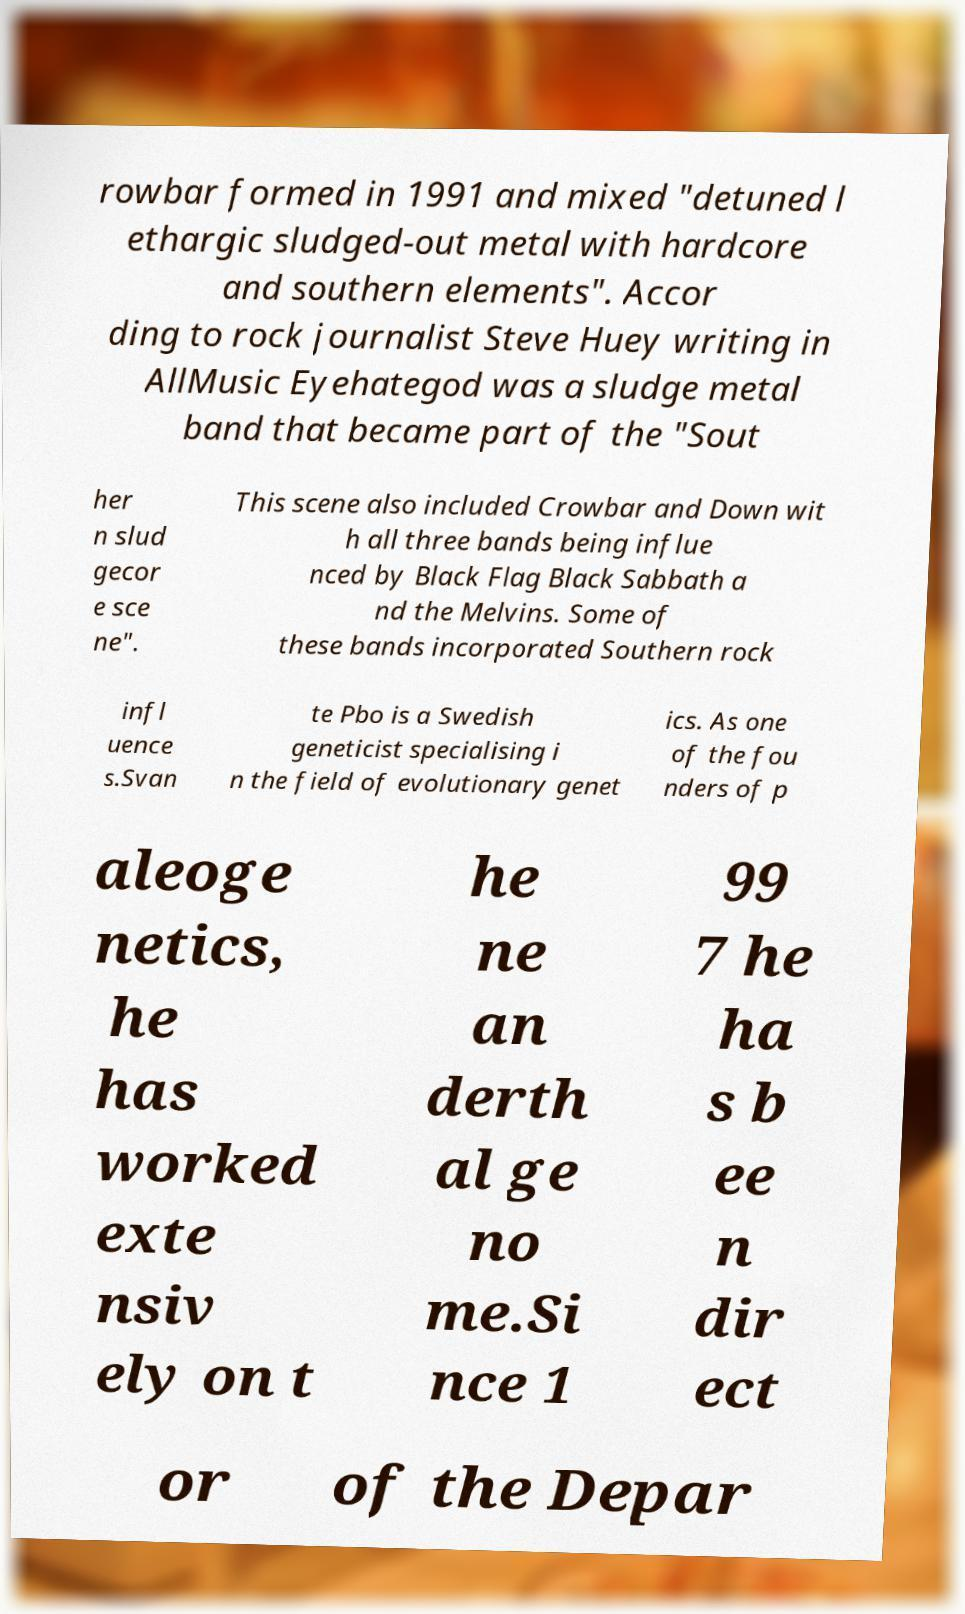What messages or text are displayed in this image? I need them in a readable, typed format. rowbar formed in 1991 and mixed "detuned l ethargic sludged-out metal with hardcore and southern elements". Accor ding to rock journalist Steve Huey writing in AllMusic Eyehategod was a sludge metal band that became part of the "Sout her n slud gecor e sce ne". This scene also included Crowbar and Down wit h all three bands being influe nced by Black Flag Black Sabbath a nd the Melvins. Some of these bands incorporated Southern rock infl uence s.Svan te Pbo is a Swedish geneticist specialising i n the field of evolutionary genet ics. As one of the fou nders of p aleoge netics, he has worked exte nsiv ely on t he ne an derth al ge no me.Si nce 1 99 7 he ha s b ee n dir ect or of the Depar 